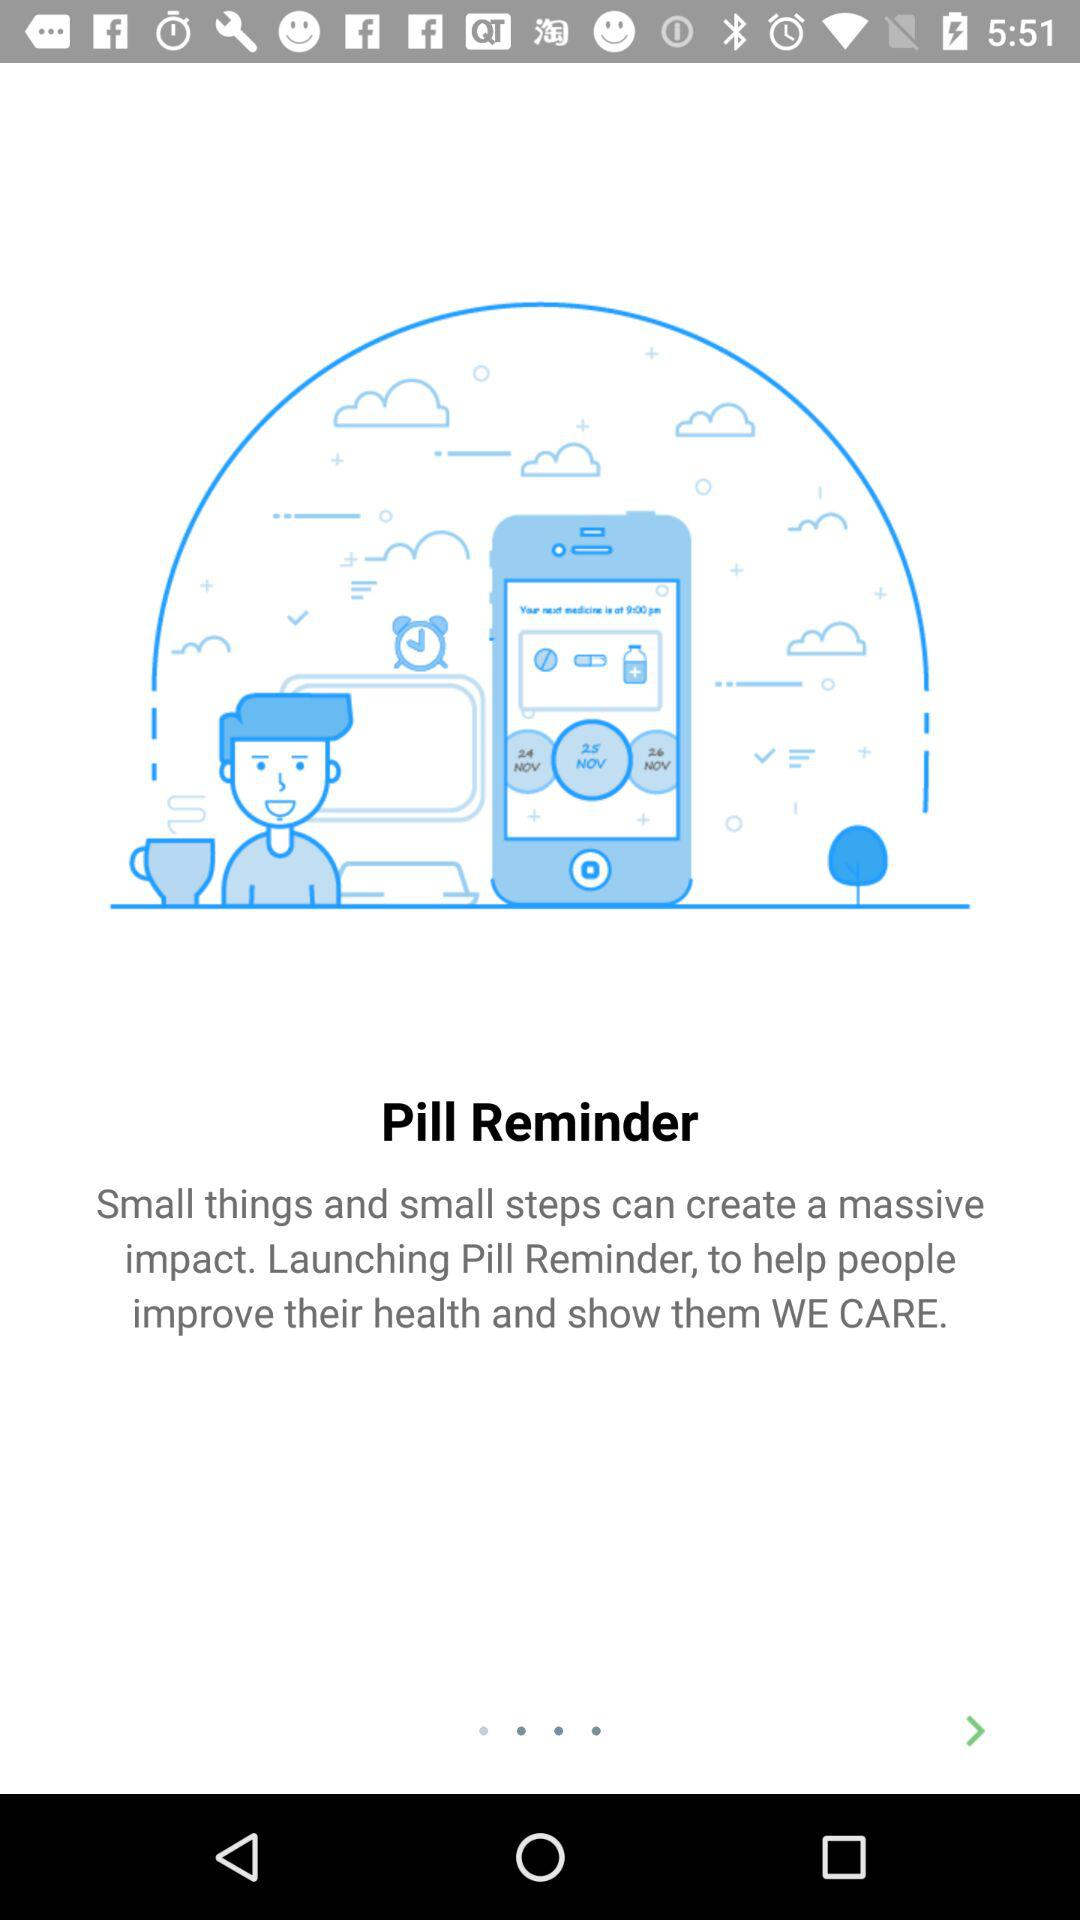What is the application name? The application name is "Pill Reminder". 